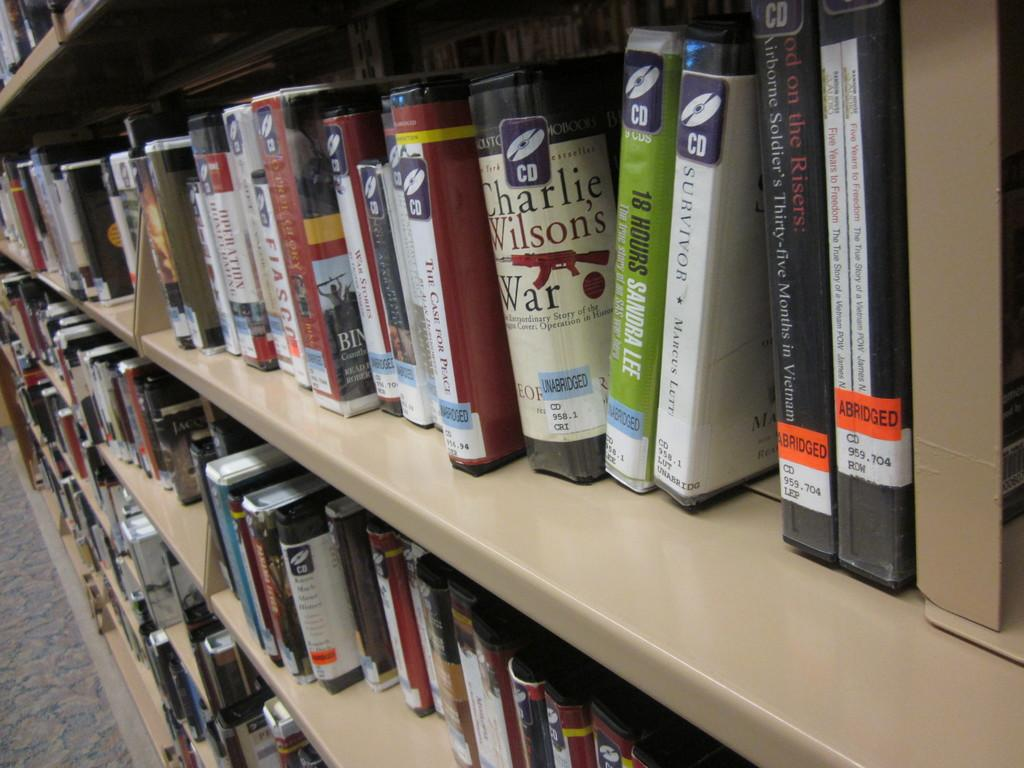<image>
Give a short and clear explanation of the subsequent image. a shelf of books with one that says 'survivor' on it 